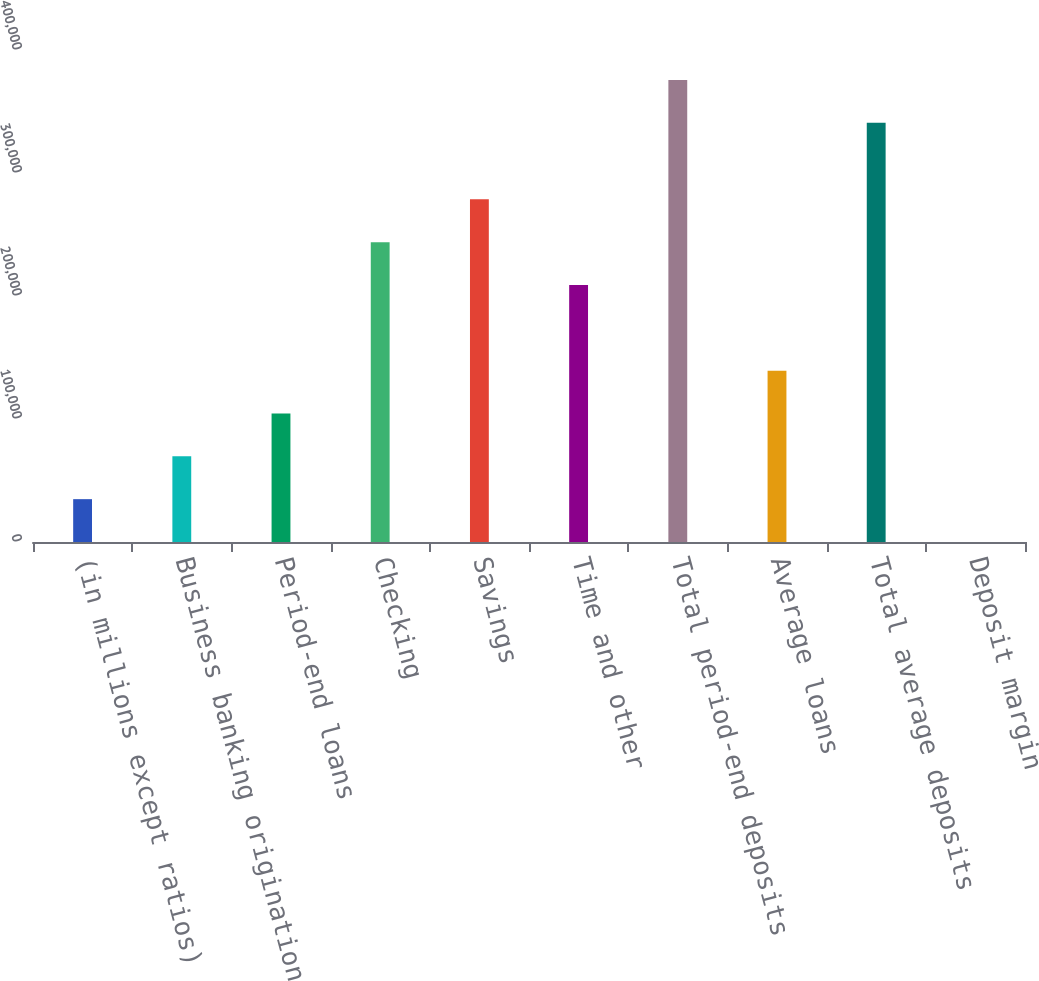Convert chart. <chart><loc_0><loc_0><loc_500><loc_500><bar_chart><fcel>(in millions except ratios)<fcel>Business banking origination<fcel>Period-end loans<fcel>Checking<fcel>Savings<fcel>Time and other<fcel>Total period-end deposits<fcel>Average loans<fcel>Total average deposits<fcel>Deposit margin<nl><fcel>34830<fcel>69657<fcel>104484<fcel>243792<fcel>278619<fcel>208965<fcel>375581<fcel>139311<fcel>340754<fcel>3<nl></chart> 